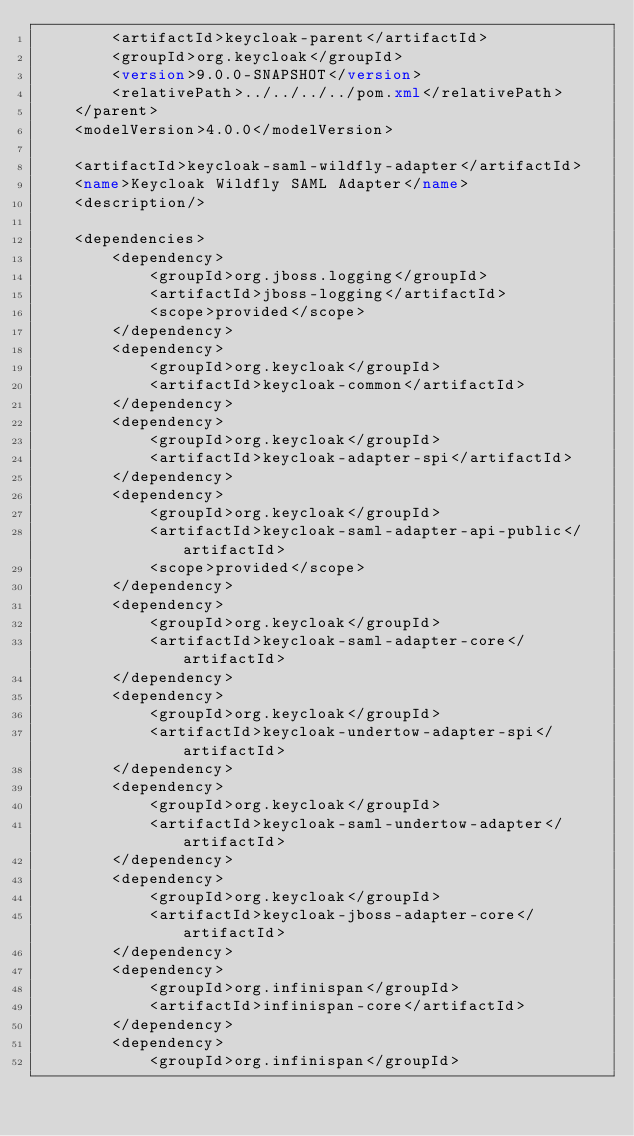<code> <loc_0><loc_0><loc_500><loc_500><_XML_>        <artifactId>keycloak-parent</artifactId>
        <groupId>org.keycloak</groupId>
        <version>9.0.0-SNAPSHOT</version>
        <relativePath>../../../../pom.xml</relativePath>
    </parent>
    <modelVersion>4.0.0</modelVersion>

    <artifactId>keycloak-saml-wildfly-adapter</artifactId>
    <name>Keycloak Wildfly SAML Adapter</name>
    <description/>

    <dependencies>
        <dependency>
            <groupId>org.jboss.logging</groupId>
            <artifactId>jboss-logging</artifactId>
            <scope>provided</scope>
        </dependency>
        <dependency>
            <groupId>org.keycloak</groupId>
            <artifactId>keycloak-common</artifactId>
        </dependency>
        <dependency>
            <groupId>org.keycloak</groupId>
            <artifactId>keycloak-adapter-spi</artifactId>
        </dependency>
        <dependency>
            <groupId>org.keycloak</groupId>
            <artifactId>keycloak-saml-adapter-api-public</artifactId>
            <scope>provided</scope>
        </dependency>
        <dependency>
            <groupId>org.keycloak</groupId>
            <artifactId>keycloak-saml-adapter-core</artifactId>
        </dependency>
        <dependency>
            <groupId>org.keycloak</groupId>
            <artifactId>keycloak-undertow-adapter-spi</artifactId>
        </dependency>
        <dependency>
            <groupId>org.keycloak</groupId>
            <artifactId>keycloak-saml-undertow-adapter</artifactId>
        </dependency>
        <dependency>
            <groupId>org.keycloak</groupId>
            <artifactId>keycloak-jboss-adapter-core</artifactId>
        </dependency>
        <dependency>
            <groupId>org.infinispan</groupId>
            <artifactId>infinispan-core</artifactId>
        </dependency>
        <dependency>
            <groupId>org.infinispan</groupId></code> 